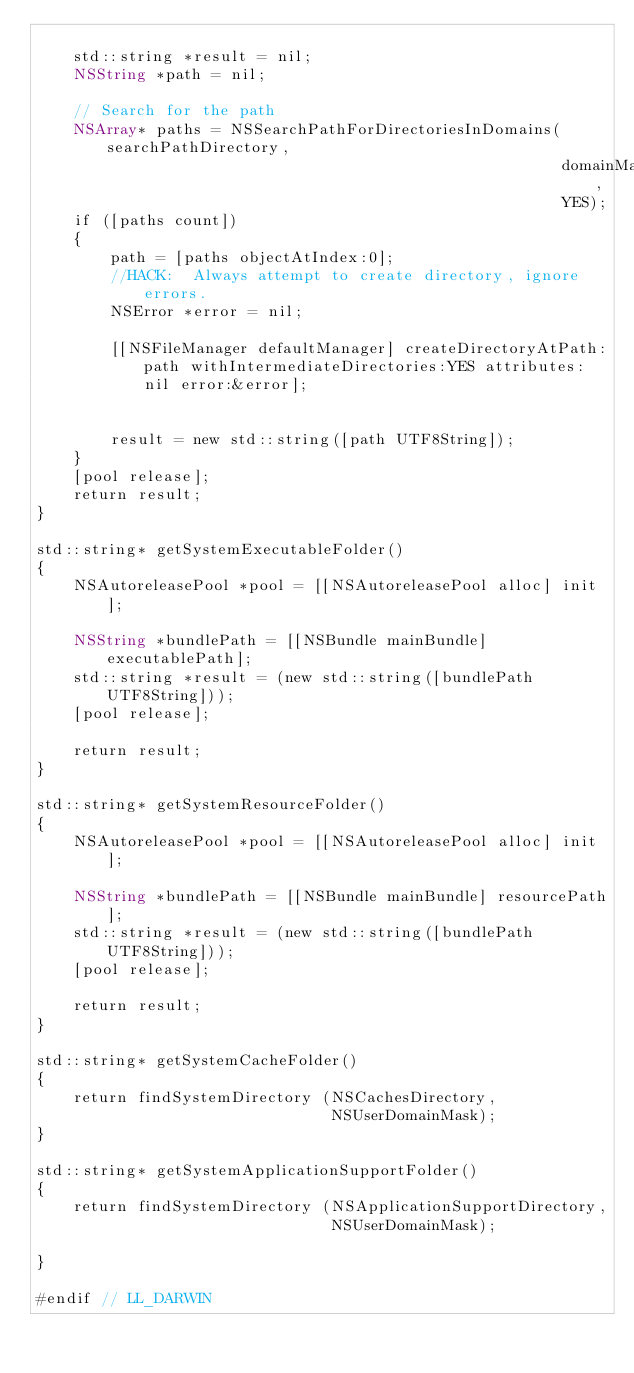<code> <loc_0><loc_0><loc_500><loc_500><_ObjectiveC_>    
    std::string *result = nil;
    NSString *path = nil;
    
    // Search for the path
    NSArray* paths = NSSearchPathForDirectoriesInDomains(searchPathDirectory,
                                                         domainMask,
                                                         YES);
    if ([paths count])
    {
        path = [paths objectAtIndex:0];
        //HACK:  Always attempt to create directory, ignore errors.
        NSError *error = nil;

        [[NSFileManager defaultManager] createDirectoryAtPath:path withIntermediateDirectories:YES attributes:nil error:&error];

        
        result = new std::string([path UTF8String]);        
    }
    [pool release];
    return result;
}

std::string* getSystemExecutableFolder()
{
    NSAutoreleasePool *pool = [[NSAutoreleasePool alloc] init];

    NSString *bundlePath = [[NSBundle mainBundle] executablePath];
    std::string *result = (new std::string([bundlePath UTF8String]));  
    [pool release];

    return result;
}

std::string* getSystemResourceFolder()
{
    NSAutoreleasePool *pool = [[NSAutoreleasePool alloc] init];

    NSString *bundlePath = [[NSBundle mainBundle] resourcePath];
    std::string *result = (new std::string([bundlePath UTF8String]));
    [pool release];
    
    return result;
}

std::string* getSystemCacheFolder()
{
    return findSystemDirectory (NSCachesDirectory,
                                NSUserDomainMask);
}

std::string* getSystemApplicationSupportFolder()
{
    return findSystemDirectory (NSApplicationSupportDirectory,
                                NSUserDomainMask);
    
}

#endif // LL_DARWIN
</code> 